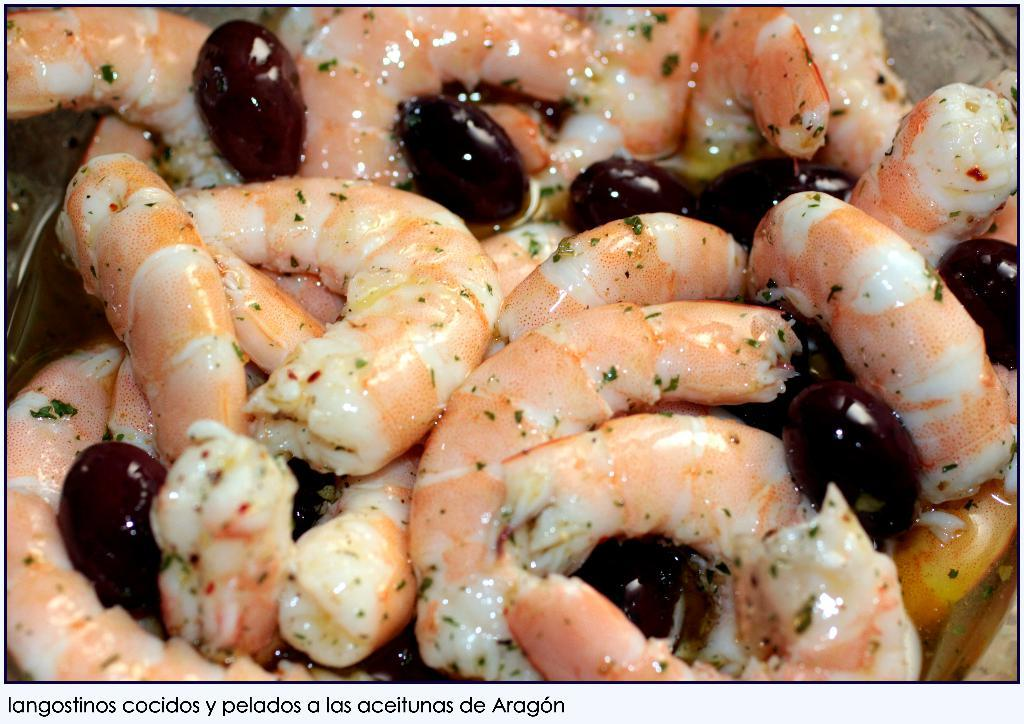What types of items can be seen in the image? There are food items in the image. Is there any text present in the image? Yes, there is text at the bottom of the image. What type of tank is visible in the image? There is no tank present in the image; it only contains food items and text. What flavor of food can be seen in the image? The provided facts do not specify the flavor of the food items in the image. 